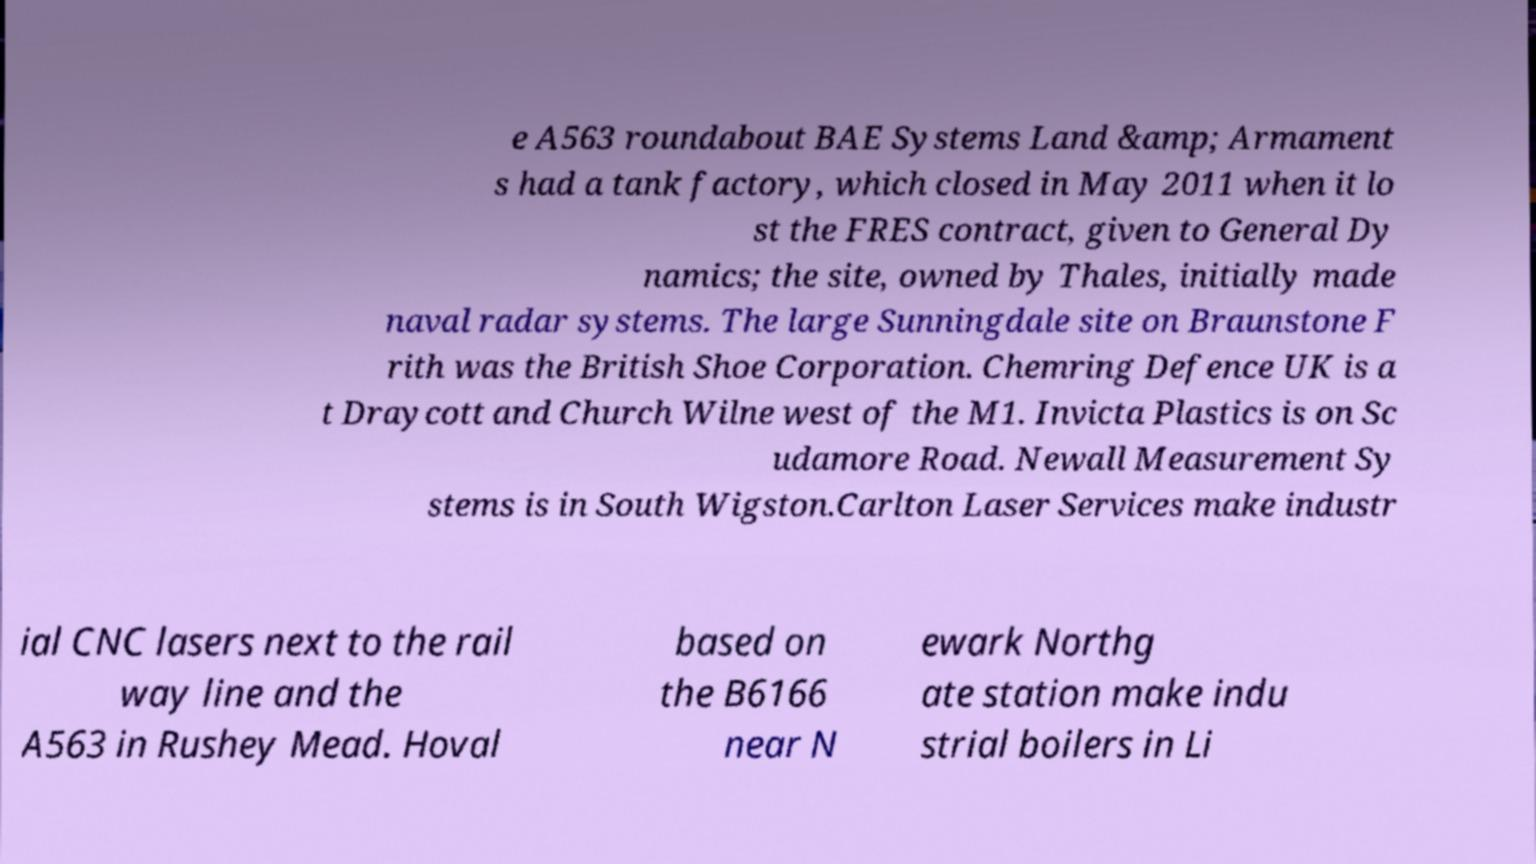I need the written content from this picture converted into text. Can you do that? e A563 roundabout BAE Systems Land &amp; Armament s had a tank factory, which closed in May 2011 when it lo st the FRES contract, given to General Dy namics; the site, owned by Thales, initially made naval radar systems. The large Sunningdale site on Braunstone F rith was the British Shoe Corporation. Chemring Defence UK is a t Draycott and Church Wilne west of the M1. Invicta Plastics is on Sc udamore Road. Newall Measurement Sy stems is in South Wigston.Carlton Laser Services make industr ial CNC lasers next to the rail way line and the A563 in Rushey Mead. Hoval based on the B6166 near N ewark Northg ate station make indu strial boilers in Li 